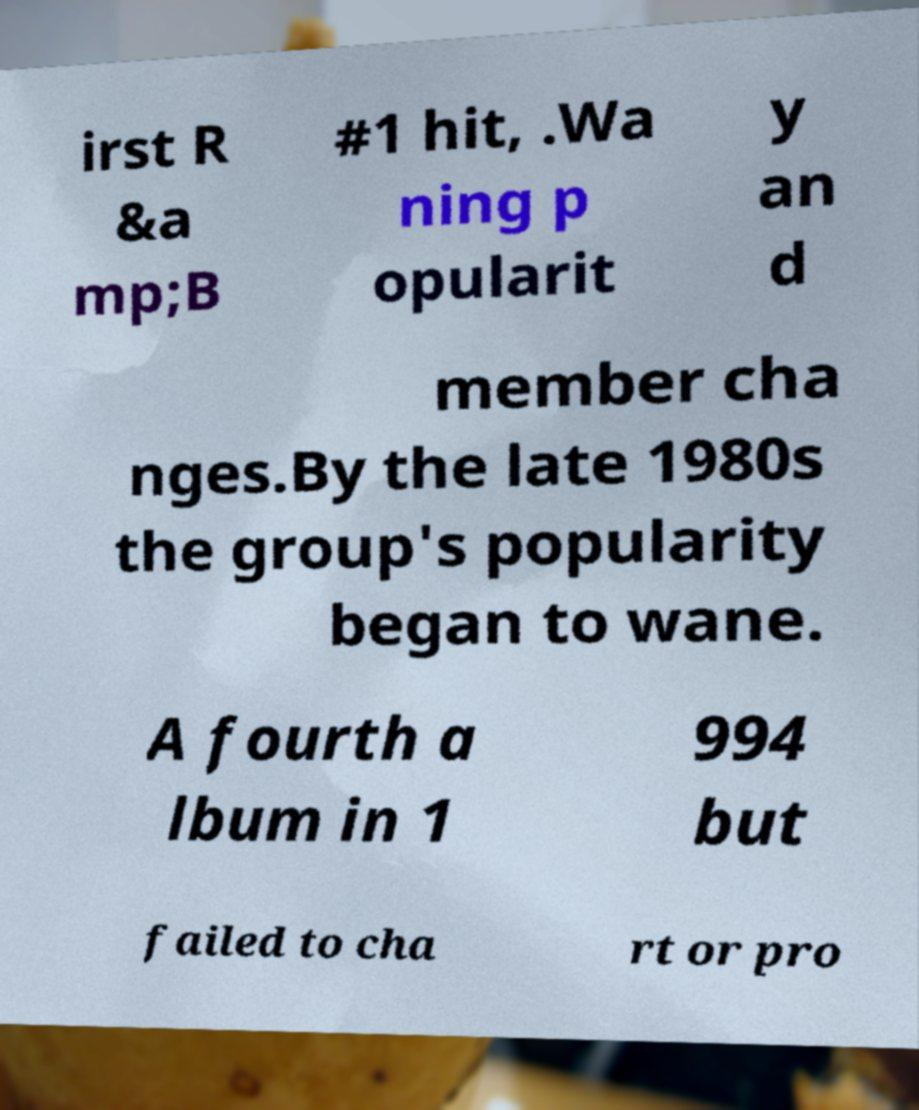Please identify and transcribe the text found in this image. irst R &a mp;B #1 hit, .Wa ning p opularit y an d member cha nges.By the late 1980s the group's popularity began to wane. A fourth a lbum in 1 994 but failed to cha rt or pro 